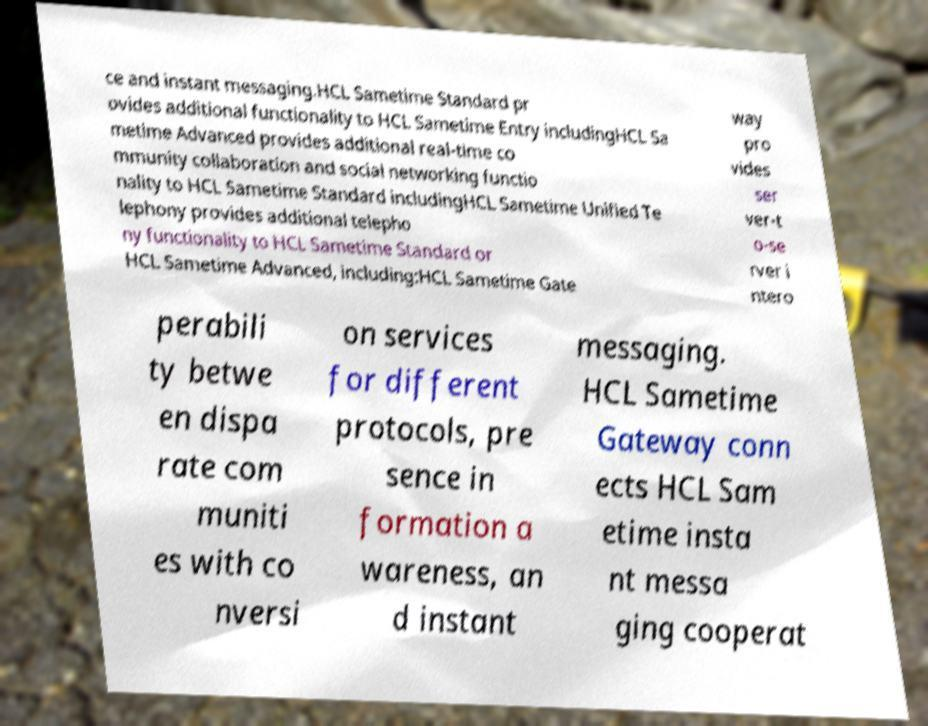Please read and relay the text visible in this image. What does it say? ce and instant messaging.HCL Sametime Standard pr ovides additional functionality to HCL Sametime Entry includingHCL Sa metime Advanced provides additional real-time co mmunity collaboration and social networking functio nality to HCL Sametime Standard includingHCL Sametime Unified Te lephony provides additional telepho ny functionality to HCL Sametime Standard or HCL Sametime Advanced, including:HCL Sametime Gate way pro vides ser ver-t o-se rver i ntero perabili ty betwe en dispa rate com muniti es with co nversi on services for different protocols, pre sence in formation a wareness, an d instant messaging. HCL Sametime Gateway conn ects HCL Sam etime insta nt messa ging cooperat 